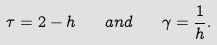<formula> <loc_0><loc_0><loc_500><loc_500>\tau = 2 - h \quad a n d \quad \gamma = \frac { 1 } { h } .</formula> 